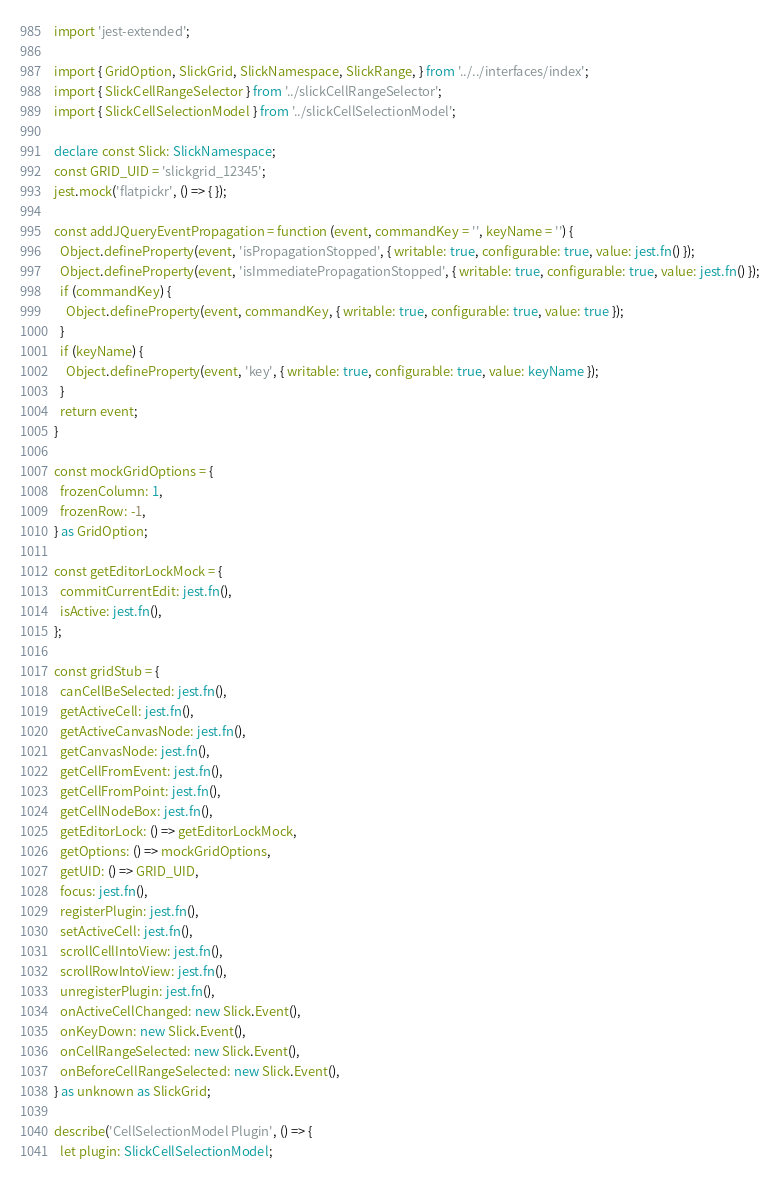<code> <loc_0><loc_0><loc_500><loc_500><_TypeScript_>import 'jest-extended';

import { GridOption, SlickGrid, SlickNamespace, SlickRange, } from '../../interfaces/index';
import { SlickCellRangeSelector } from '../slickCellRangeSelector';
import { SlickCellSelectionModel } from '../slickCellSelectionModel';

declare const Slick: SlickNamespace;
const GRID_UID = 'slickgrid_12345';
jest.mock('flatpickr', () => { });

const addJQueryEventPropagation = function (event, commandKey = '', keyName = '') {
  Object.defineProperty(event, 'isPropagationStopped', { writable: true, configurable: true, value: jest.fn() });
  Object.defineProperty(event, 'isImmediatePropagationStopped', { writable: true, configurable: true, value: jest.fn() });
  if (commandKey) {
    Object.defineProperty(event, commandKey, { writable: true, configurable: true, value: true });
  }
  if (keyName) {
    Object.defineProperty(event, 'key', { writable: true, configurable: true, value: keyName });
  }
  return event;
}

const mockGridOptions = {
  frozenColumn: 1,
  frozenRow: -1,
} as GridOption;

const getEditorLockMock = {
  commitCurrentEdit: jest.fn(),
  isActive: jest.fn(),
};

const gridStub = {
  canCellBeSelected: jest.fn(),
  getActiveCell: jest.fn(),
  getActiveCanvasNode: jest.fn(),
  getCanvasNode: jest.fn(),
  getCellFromEvent: jest.fn(),
  getCellFromPoint: jest.fn(),
  getCellNodeBox: jest.fn(),
  getEditorLock: () => getEditorLockMock,
  getOptions: () => mockGridOptions,
  getUID: () => GRID_UID,
  focus: jest.fn(),
  registerPlugin: jest.fn(),
  setActiveCell: jest.fn(),
  scrollCellIntoView: jest.fn(),
  scrollRowIntoView: jest.fn(),
  unregisterPlugin: jest.fn(),
  onActiveCellChanged: new Slick.Event(),
  onKeyDown: new Slick.Event(),
  onCellRangeSelected: new Slick.Event(),
  onBeforeCellRangeSelected: new Slick.Event(),
} as unknown as SlickGrid;

describe('CellSelectionModel Plugin', () => {
  let plugin: SlickCellSelectionModel;</code> 